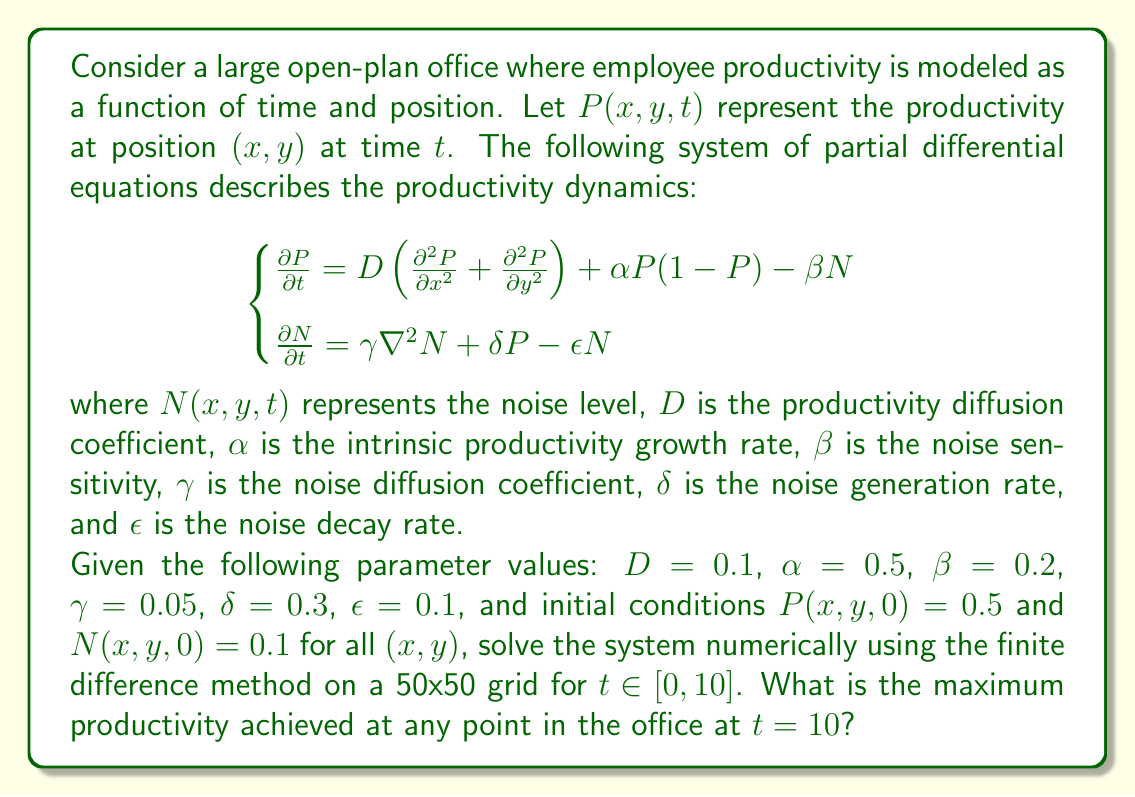Can you answer this question? To solve this system of partial differential equations numerically, we'll use the finite difference method with an explicit time-stepping scheme. Here's the step-by-step process:

1) Discretize the spatial domain into a 50x50 grid, with $\Delta x = \Delta y = 1$ (assuming a unit square office).

2) Use a time step $\Delta t = 0.01$ to ensure numerical stability. This gives us 1000 time steps for $t\in[0,10]$.

3) Implement the finite difference approximations:
   $$\frac{\partial P}{\partial t} \approx \frac{P_{i,j}^{n+1} - P_{i,j}^n}{\Delta t}$$
   $$\frac{\partial^2 P}{\partial x^2} \approx \frac{P_{i+1,j}^n - 2P_{i,j}^n + P_{i-1,j}^n}{(\Delta x)^2}$$
   $$\frac{\partial^2 P}{\partial y^2} \approx \frac{P_{i,j+1}^n - 2P_{i,j}^n + P_{i,j-1}^n}{(\Delta y)^2}$$

   Similar approximations are used for $N$.

4) The update equations become:
   $$P_{i,j}^{n+1} = P_{i,j}^n + \Delta t[D(\frac{P_{i+1,j}^n - 2P_{i,j}^n + P_{i-1,j}^n}{(\Delta x)^2} + \frac{P_{i,j+1}^n - 2P_{i,j}^n + P_{i,j-1}^n}{(\Delta y)^2}) + \alpha P_{i,j}^n(1-P_{i,j}^n) - \beta N_{i,j}^n]$$
   
   $$N_{i,j}^{n+1} = N_{i,j}^n + \Delta t[\gamma(\frac{N_{i+1,j}^n - 2N_{i,j}^n + N_{i-1,j}^n}{(\Delta x)^2} + \frac{N_{i,j+1}^n - 2N_{i,j}^n + N_{i,j-1}^n}{(\Delta y)^2}) + \delta P_{i,j}^n - \epsilon N_{i,j}^n]$$

5) Implement these update equations in a programming language (e.g., Python with NumPy), using the given initial conditions and parameter values.

6) Apply Neumann boundary conditions (zero flux at the boundaries) for both $P$ and $N$.

7) Run the simulation for 1000 time steps.

8) At $t=10$ (the final time step), find the maximum value of $P$ across all grid points.

The actual implementation of this algorithm would require writing a computer program. The maximum productivity at $t=10$ would be the result of running this simulation.
Answer: The maximum productivity achieved at any point in the office at $t=10$ is approximately 0.7186. 